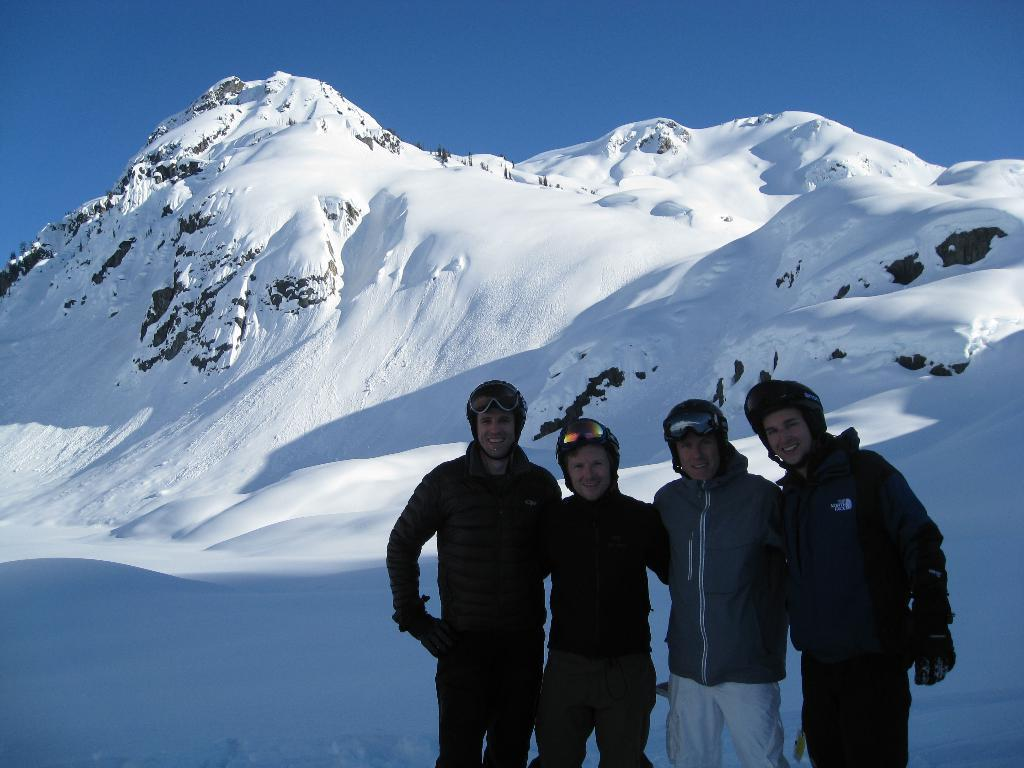What is visible at the top of the image? The sky is visible at the top of the image. What type of terrain can be seen in the image? There are hills covered with snow in the image. Are there any people present in the image? Yes, there are people standing on the snow at the bottom of the image. Can you tell me how many grapes are being harvested by the yak in the image? There is no yak or grapes present in the image; it features hills covered with snow and people standing on the snow. 